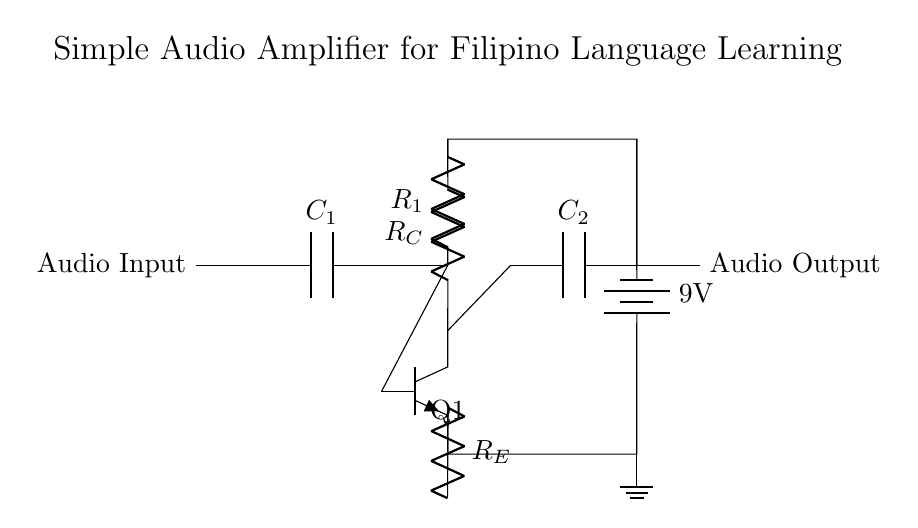What is the type of transistor used in this circuit? The circuit diagram indicates the use of an NPN transistor, identified by the notation "npn" in the diagram. An NPN transistor is characterized by having two n-type semiconductors and one p-type semiconductor.
Answer: NPN What is the value of the battery voltage? The circuit shows a 9V battery, labeled directly in the diagram next to the battery component, indicating the power supply voltage for the circuit.
Answer: 9V What is the purpose of capacitor C1? Capacitor C1 acts as a coupling capacitor, which allows AC signals (audio input) to pass through while blocking any DC components. This is critical in audio circuits to avoid distortion.
Answer: Coupling What is the role of resistor R1 in the circuit? Resistor R1 is used for biasing the transistor, setting the operating point to ensure the transistor functions in the active region and amplifies the input audio signal correctly.
Answer: Biasing What happens to the audio output if resistor R_E is removed? Removing resistor R_E would significantly affect the stability and gain of the transistor, potentially leading to distortion or cutoff in the amplification of the audio signal.
Answer: Instability How many capacitors are present in the circuit? The diagram shows two capacitors labeled as C1 and C2, which are used for coupling and output filtering. Each serves a distinct function in managing the audio signal.
Answer: Two 